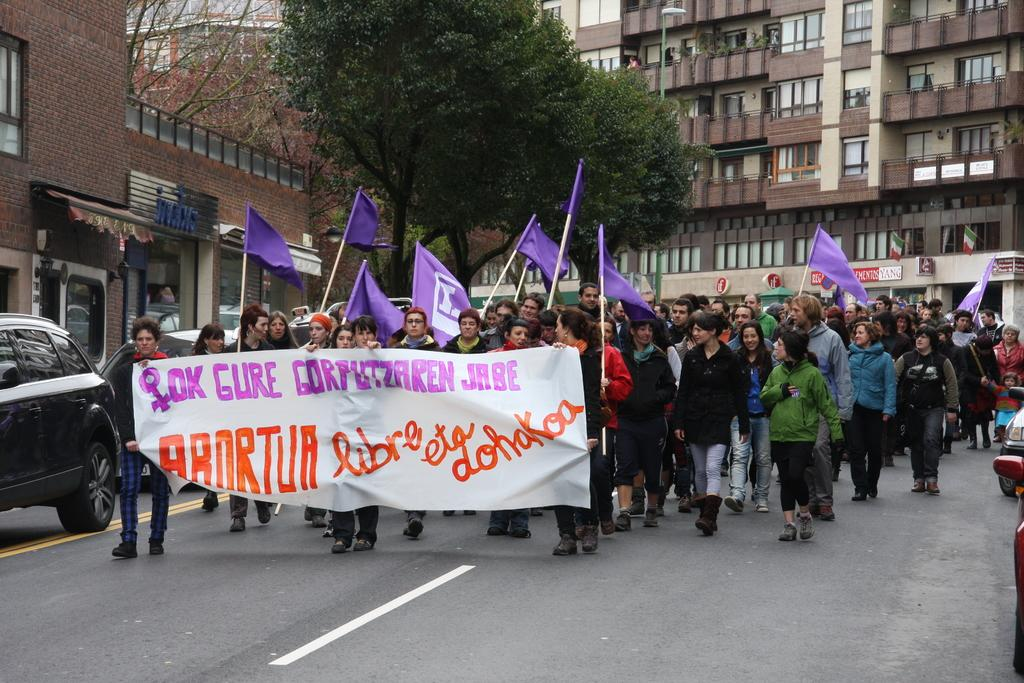Who are the subjects in the image? There are people in the image. What are the people holding in the image? The people are holding flags and a banner. What activity are the people engaged in? They are protesting on a road. What else can be seen in the image besides the people? There are cars visible in the image. What is visible in the background of the image? There are buildings and trees in the background of the image. How many brothers are shaking hands in the image? There are no brothers or handshakes present in the image. 